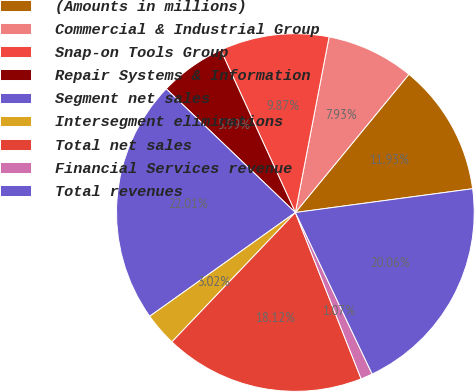Convert chart. <chart><loc_0><loc_0><loc_500><loc_500><pie_chart><fcel>(Amounts in millions)<fcel>Commercial & Industrial Group<fcel>Snap-on Tools Group<fcel>Repair Systems & Information<fcel>Segment net sales<fcel>Intersegment eliminations<fcel>Total net sales<fcel>Financial Services revenue<fcel>Total revenues<nl><fcel>11.93%<fcel>7.93%<fcel>9.87%<fcel>5.99%<fcel>22.01%<fcel>3.02%<fcel>18.12%<fcel>1.07%<fcel>20.06%<nl></chart> 